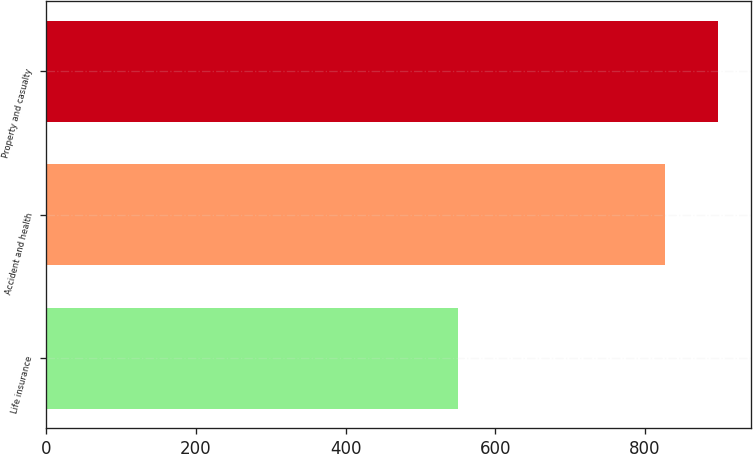Convert chart to OTSL. <chart><loc_0><loc_0><loc_500><loc_500><bar_chart><fcel>Life insurance<fcel>Accident and health<fcel>Property and casualty<nl><fcel>550<fcel>827<fcel>897<nl></chart> 